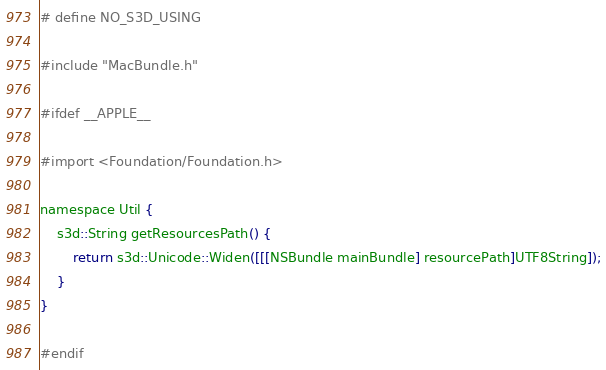<code> <loc_0><loc_0><loc_500><loc_500><_ObjectiveC_># define NO_S3D_USING

#include "MacBundle.h"

#ifdef __APPLE__

#import <Foundation/Foundation.h>

namespace Util {
    s3d::String getResourcesPath() {
        return s3d::Unicode::Widen([[[NSBundle mainBundle] resourcePath]UTF8String]);
    }
}

#endif

</code> 